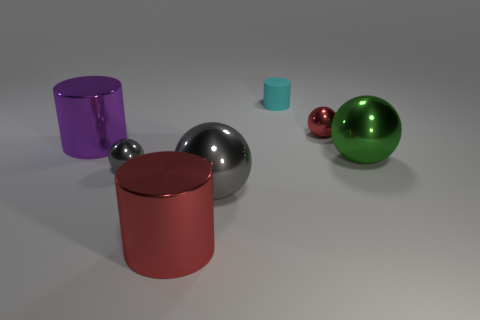Is there any other thing that has the same material as the small cyan thing?
Make the answer very short. No. What is the large green object made of?
Give a very brief answer. Metal. Does the small gray object have the same shape as the metallic object behind the big purple metallic cylinder?
Your answer should be very brief. Yes. There is a tiny red thing that is behind the small metallic sphere that is left of the cyan matte object right of the red metal cylinder; what is it made of?
Make the answer very short. Metal. How many shiny balls are there?
Offer a terse response. 4. How many green objects are either tiny matte cylinders or large things?
Your answer should be very brief. 1. How many other things are there of the same shape as the purple thing?
Offer a terse response. 2. There is a metal object in front of the big gray thing; is its color the same as the tiny metallic thing that is behind the purple thing?
Keep it short and to the point. Yes. What number of big objects are either cyan matte cylinders or red metallic cubes?
Make the answer very short. 0. There is another gray shiny object that is the same shape as the small gray object; what size is it?
Your answer should be very brief. Large. 